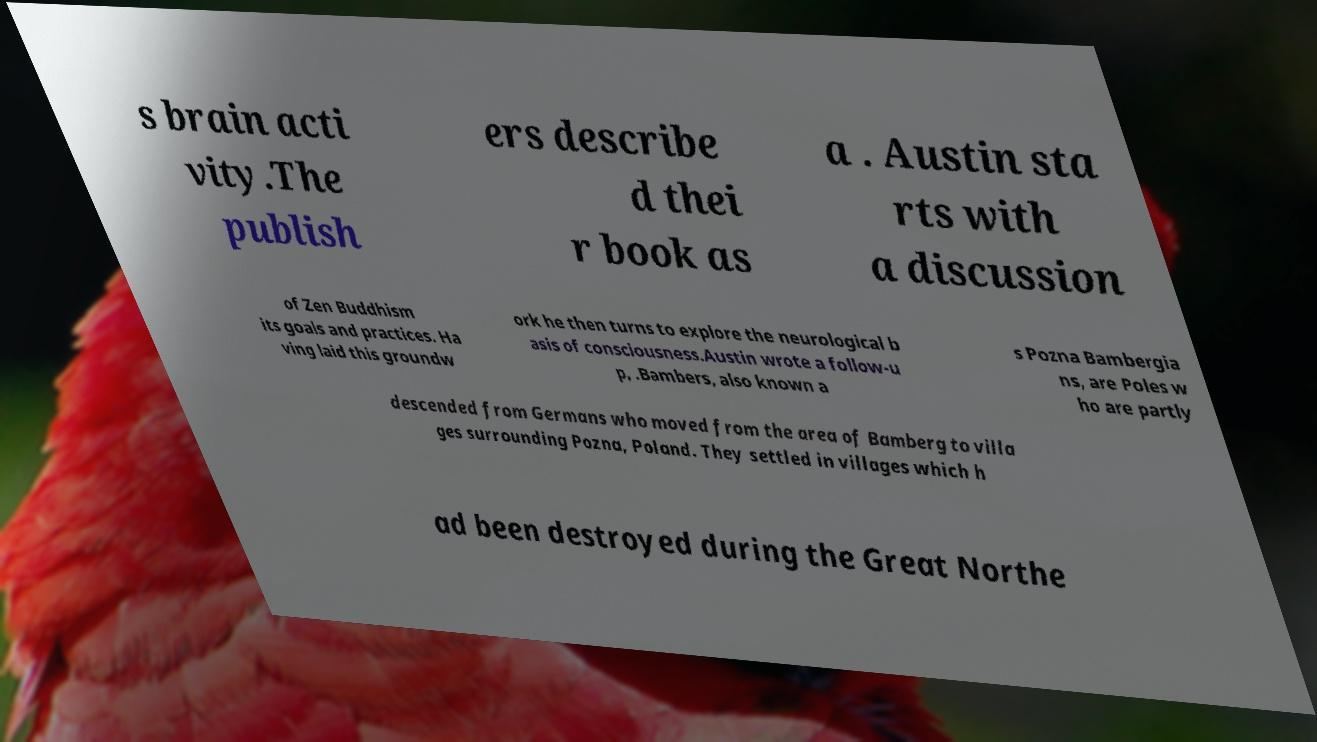I need the written content from this picture converted into text. Can you do that? s brain acti vity.The publish ers describe d thei r book as a . Austin sta rts with a discussion of Zen Buddhism its goals and practices. Ha ving laid this groundw ork he then turns to explore the neurological b asis of consciousness.Austin wrote a follow-u p, .Bambers, also known a s Pozna Bambergia ns, are Poles w ho are partly descended from Germans who moved from the area of Bamberg to villa ges surrounding Pozna, Poland. They settled in villages which h ad been destroyed during the Great Northe 